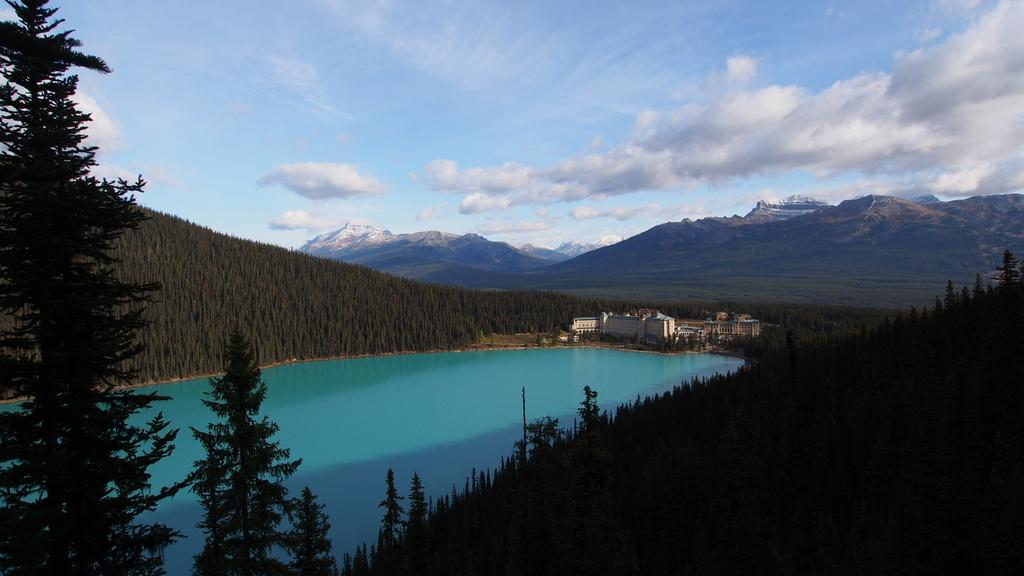What type of natural elements can be seen in the image? There are trees and mountains visible in the image. What type of man-made structures can be seen in the image? There are buildings visible in the image. What is the water feature in the image? There is water visible in the image. What is visible in the sky at the top of the image? There are clouds in the sky at the top of the image. Can you see any fangs on the trees in the image? There are no fangs present on the trees in the image; they are natural elements with branches and leaves. What type of stove is visible in the image? There is no stove present in the image. 